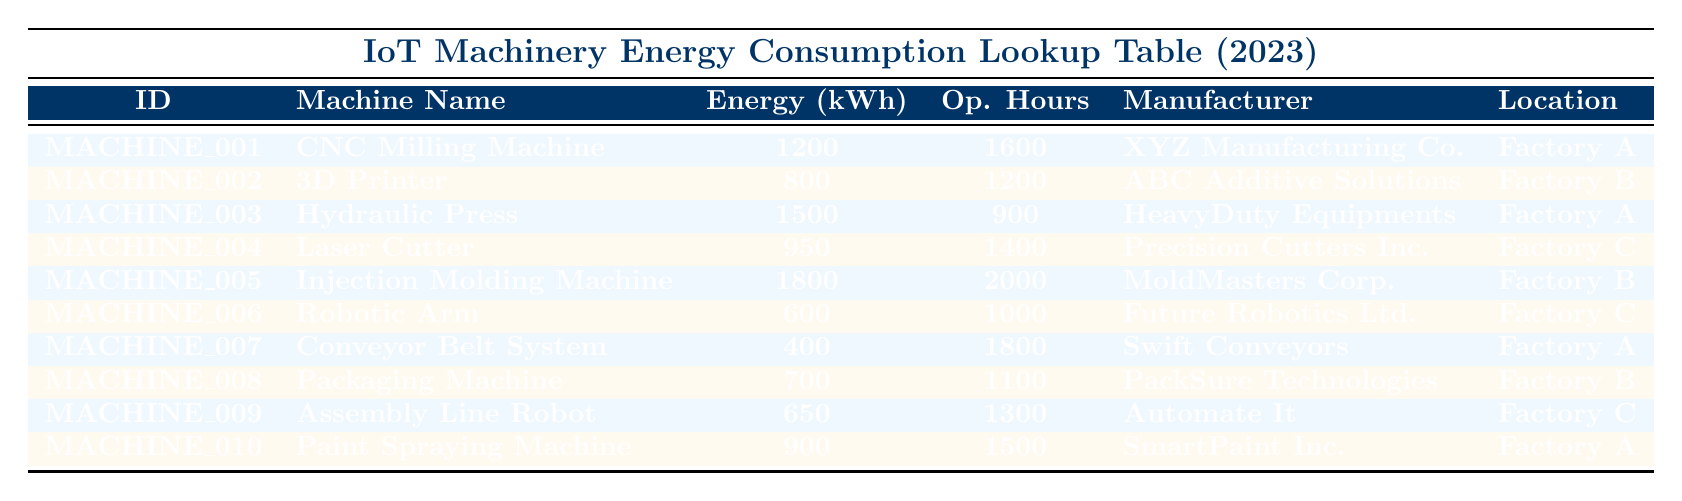What is the energy consumption of the CNC Milling Machine? The table lists the CNC Milling Machine under "Machine Name" with an Energy Consumption value of 1200 kWh in the corresponding row.
Answer: 1200 kWh Which machine has the highest energy consumption and what is that value? By reviewing the Energy Consumption column, the Injection Molding Machine has the highest value at 1800 kWh, as observed in its respective row.
Answer: 1800 kWh How many operational hours did the Hydraulic Press operate? The operational hours for the Hydraulic Press can be found in its row under "Operational Hours," which indicates it operated for 900 hours.
Answer: 900 hours What is the total energy consumption of all machines located in Factory A? The energy consumption of each machine in Factory A is taken (CNC Milling Machine 1200 kWh, Hydraulic Press 1500 kWh, Conveyor Belt System 400 kWh, Paint Spraying Machine 900 kWh). Adding these gives: 1200 + 1500 + 400 + 900 = 4000 kWh.
Answer: 4000 kWh Is the 3D Printer manufactured by ABC Additive Solutions? The table confirms that the 3D Printer is indeed listed as being manufactured by ABC Additive Solutions in the corresponding row.
Answer: Yes What is the average energy consumption of all machines in Factory B? The machines in Factory B are the 3D Printer (800 kWh), Injection Molding Machine (1800 kWh), and Packaging Machine (700 kWh). Summing them gives 800 + 1800 + 700 = 3300 kWh. There are 3 machines, calculating the average: 3300 / 3 = 1100 kWh.
Answer: 1100 kWh Does any machine in the table consume less than 500 kWh of energy? The table lists all energy consumption values, and the lowest is for the Conveyor Belt System, which consumes 400 kWh, indicating that yes, there is a machine that consumes less than 500 kWh.
Answer: Yes How many machines have operational hours greater than 1500? A review of the "Operational Hours" column shows that the CNC Milling Machine (1600), Injection Molding Machine (2000), and Paint Spraying Machine (1500) exceed 1500 hours. This totals to 3 machines.
Answer: 3 machines What is the energy consumption difference between the Injection Molding Machine and the Robotic Arm? The Injection Molding Machine consumes 1800 kWh while the Robotic Arm consumes 600 kWh. The difference is calculated as 1800 - 600 = 1200 kWh.
Answer: 1200 kWh 